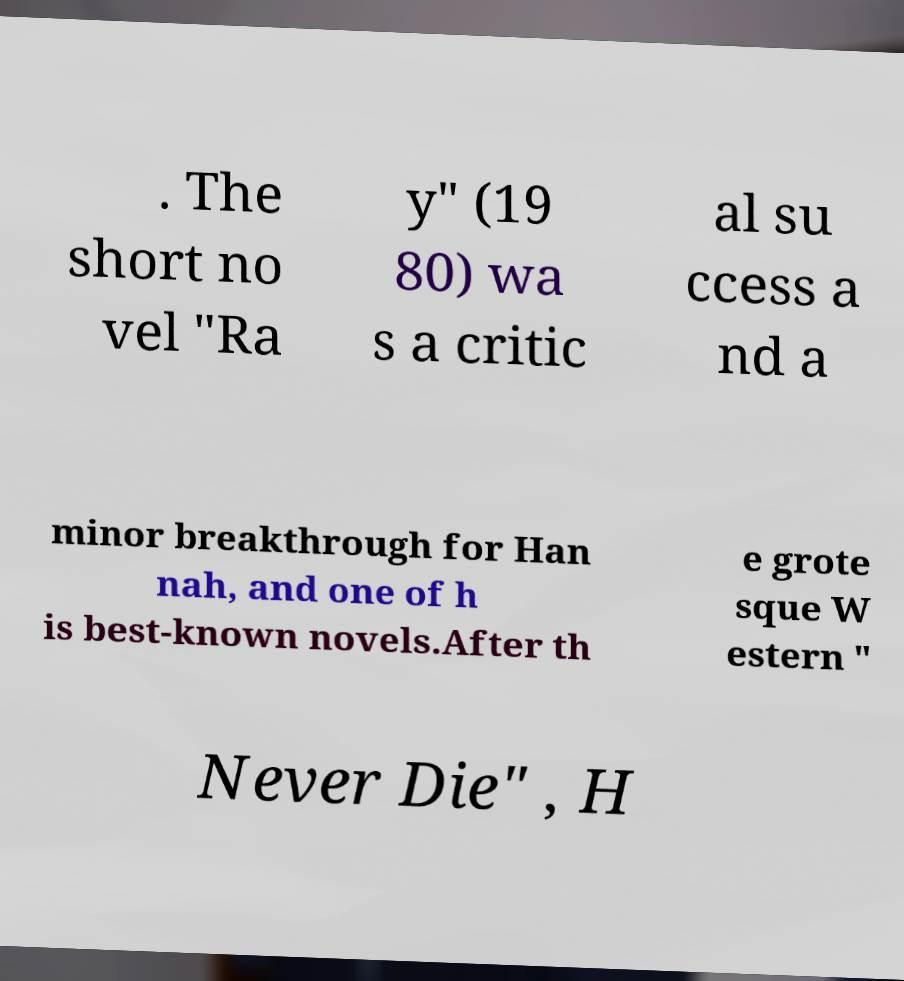Please read and relay the text visible in this image. What does it say? . The short no vel "Ra y" (19 80) wa s a critic al su ccess a nd a minor breakthrough for Han nah, and one of h is best-known novels.After th e grote sque W estern " Never Die" , H 